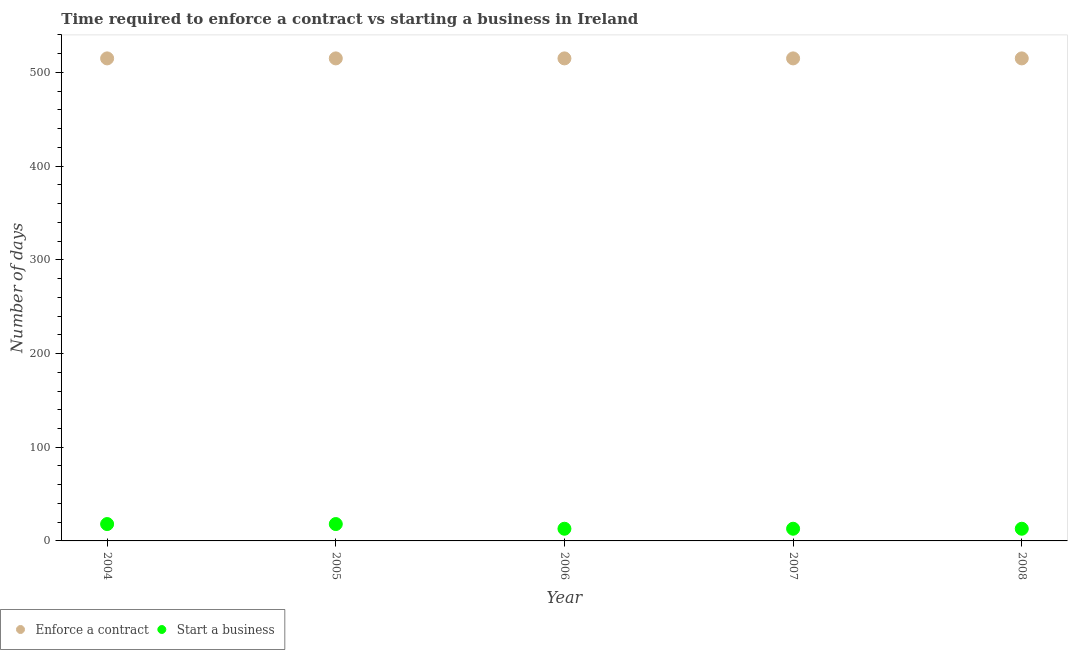How many different coloured dotlines are there?
Ensure brevity in your answer.  2. What is the number of days to start a business in 2007?
Provide a succinct answer. 13. Across all years, what is the maximum number of days to enforece a contract?
Provide a short and direct response. 515. Across all years, what is the minimum number of days to start a business?
Provide a short and direct response. 13. In which year was the number of days to enforece a contract minimum?
Make the answer very short. 2004. What is the total number of days to enforece a contract in the graph?
Give a very brief answer. 2575. What is the difference between the number of days to start a business in 2006 and that in 2008?
Give a very brief answer. 0. What is the difference between the number of days to enforece a contract in 2006 and the number of days to start a business in 2004?
Give a very brief answer. 497. What is the average number of days to enforece a contract per year?
Give a very brief answer. 515. In the year 2006, what is the difference between the number of days to enforece a contract and number of days to start a business?
Provide a short and direct response. 502. What is the ratio of the number of days to start a business in 2004 to that in 2006?
Offer a terse response. 1.38. Is the number of days to enforece a contract in 2004 less than that in 2008?
Ensure brevity in your answer.  No. What is the difference between the highest and the second highest number of days to enforece a contract?
Provide a succinct answer. 0. What is the difference between the highest and the lowest number of days to start a business?
Your answer should be compact. 5. Is the sum of the number of days to start a business in 2004 and 2006 greater than the maximum number of days to enforece a contract across all years?
Provide a short and direct response. No. Does the number of days to start a business monotonically increase over the years?
Your answer should be very brief. No. Is the number of days to enforece a contract strictly greater than the number of days to start a business over the years?
Make the answer very short. Yes. Is the number of days to enforece a contract strictly less than the number of days to start a business over the years?
Your answer should be very brief. No. How many dotlines are there?
Your answer should be very brief. 2. Does the graph contain any zero values?
Ensure brevity in your answer.  No. Where does the legend appear in the graph?
Your response must be concise. Bottom left. How many legend labels are there?
Provide a succinct answer. 2. What is the title of the graph?
Your response must be concise. Time required to enforce a contract vs starting a business in Ireland. Does "Agricultural land" appear as one of the legend labels in the graph?
Give a very brief answer. No. What is the label or title of the Y-axis?
Provide a succinct answer. Number of days. What is the Number of days of Enforce a contract in 2004?
Your answer should be compact. 515. What is the Number of days of Enforce a contract in 2005?
Your answer should be very brief. 515. What is the Number of days in Start a business in 2005?
Your answer should be compact. 18. What is the Number of days in Enforce a contract in 2006?
Keep it short and to the point. 515. What is the Number of days of Start a business in 2006?
Ensure brevity in your answer.  13. What is the Number of days in Enforce a contract in 2007?
Your answer should be compact. 515. What is the Number of days in Enforce a contract in 2008?
Ensure brevity in your answer.  515. What is the Number of days in Start a business in 2008?
Provide a succinct answer. 13. Across all years, what is the maximum Number of days of Enforce a contract?
Give a very brief answer. 515. Across all years, what is the minimum Number of days in Enforce a contract?
Your response must be concise. 515. Across all years, what is the minimum Number of days in Start a business?
Your answer should be very brief. 13. What is the total Number of days in Enforce a contract in the graph?
Provide a succinct answer. 2575. What is the total Number of days of Start a business in the graph?
Offer a very short reply. 75. What is the difference between the Number of days in Start a business in 2004 and that in 2006?
Provide a succinct answer. 5. What is the difference between the Number of days of Enforce a contract in 2004 and that in 2007?
Give a very brief answer. 0. What is the difference between the Number of days in Start a business in 2004 and that in 2008?
Your response must be concise. 5. What is the difference between the Number of days in Enforce a contract in 2005 and that in 2006?
Make the answer very short. 0. What is the difference between the Number of days in Start a business in 2005 and that in 2006?
Your response must be concise. 5. What is the difference between the Number of days in Start a business in 2005 and that in 2007?
Your answer should be compact. 5. What is the difference between the Number of days of Start a business in 2005 and that in 2008?
Your response must be concise. 5. What is the difference between the Number of days in Enforce a contract in 2004 and the Number of days in Start a business in 2005?
Your answer should be compact. 497. What is the difference between the Number of days of Enforce a contract in 2004 and the Number of days of Start a business in 2006?
Ensure brevity in your answer.  502. What is the difference between the Number of days of Enforce a contract in 2004 and the Number of days of Start a business in 2007?
Provide a short and direct response. 502. What is the difference between the Number of days of Enforce a contract in 2004 and the Number of days of Start a business in 2008?
Offer a very short reply. 502. What is the difference between the Number of days of Enforce a contract in 2005 and the Number of days of Start a business in 2006?
Your answer should be very brief. 502. What is the difference between the Number of days of Enforce a contract in 2005 and the Number of days of Start a business in 2007?
Give a very brief answer. 502. What is the difference between the Number of days of Enforce a contract in 2005 and the Number of days of Start a business in 2008?
Make the answer very short. 502. What is the difference between the Number of days in Enforce a contract in 2006 and the Number of days in Start a business in 2007?
Give a very brief answer. 502. What is the difference between the Number of days of Enforce a contract in 2006 and the Number of days of Start a business in 2008?
Give a very brief answer. 502. What is the difference between the Number of days in Enforce a contract in 2007 and the Number of days in Start a business in 2008?
Ensure brevity in your answer.  502. What is the average Number of days in Enforce a contract per year?
Your response must be concise. 515. In the year 2004, what is the difference between the Number of days of Enforce a contract and Number of days of Start a business?
Provide a succinct answer. 497. In the year 2005, what is the difference between the Number of days of Enforce a contract and Number of days of Start a business?
Your response must be concise. 497. In the year 2006, what is the difference between the Number of days in Enforce a contract and Number of days in Start a business?
Your answer should be compact. 502. In the year 2007, what is the difference between the Number of days in Enforce a contract and Number of days in Start a business?
Make the answer very short. 502. In the year 2008, what is the difference between the Number of days in Enforce a contract and Number of days in Start a business?
Make the answer very short. 502. What is the ratio of the Number of days in Enforce a contract in 2004 to that in 2005?
Your answer should be very brief. 1. What is the ratio of the Number of days in Start a business in 2004 to that in 2006?
Provide a succinct answer. 1.38. What is the ratio of the Number of days in Start a business in 2004 to that in 2007?
Make the answer very short. 1.38. What is the ratio of the Number of days in Start a business in 2004 to that in 2008?
Your answer should be very brief. 1.38. What is the ratio of the Number of days of Start a business in 2005 to that in 2006?
Your response must be concise. 1.38. What is the ratio of the Number of days of Enforce a contract in 2005 to that in 2007?
Provide a succinct answer. 1. What is the ratio of the Number of days in Start a business in 2005 to that in 2007?
Give a very brief answer. 1.38. What is the ratio of the Number of days in Start a business in 2005 to that in 2008?
Offer a terse response. 1.38. What is the ratio of the Number of days of Start a business in 2006 to that in 2007?
Your response must be concise. 1. What is the ratio of the Number of days in Enforce a contract in 2007 to that in 2008?
Your answer should be compact. 1. What is the difference between the highest and the second highest Number of days of Enforce a contract?
Provide a succinct answer. 0. What is the difference between the highest and the lowest Number of days of Enforce a contract?
Your response must be concise. 0. What is the difference between the highest and the lowest Number of days in Start a business?
Your answer should be compact. 5. 